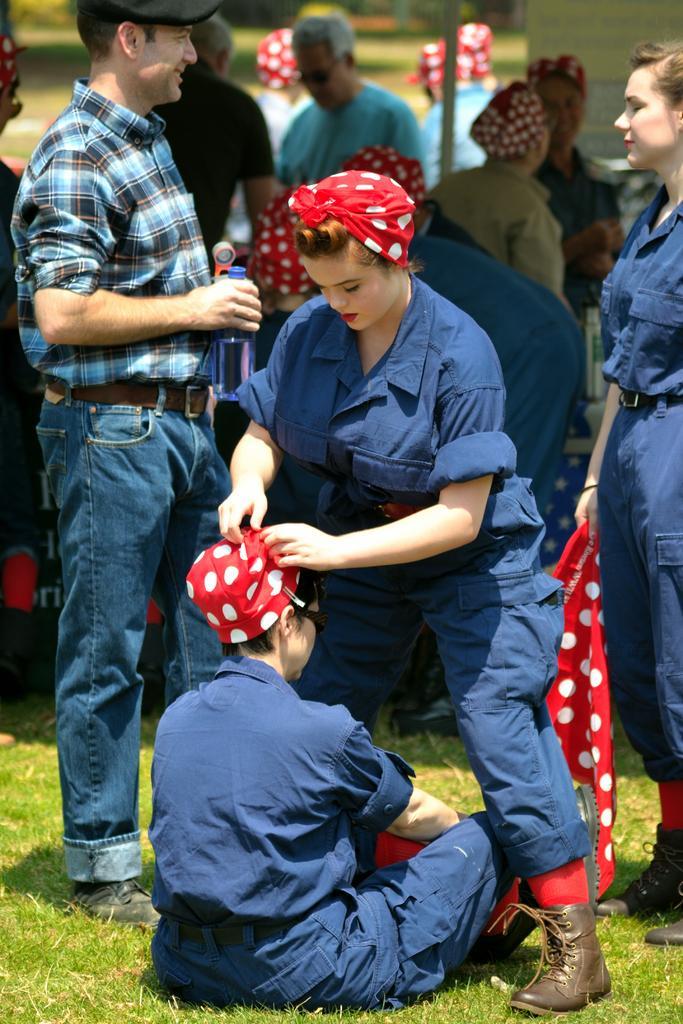Could you give a brief overview of what you see in this image? In the picture I can see people among them some are standing and one of the person is sitting on the ground. I can also see the man on the left side holding an object in the hand. The background of the image is blurred and I can also see the grass. 